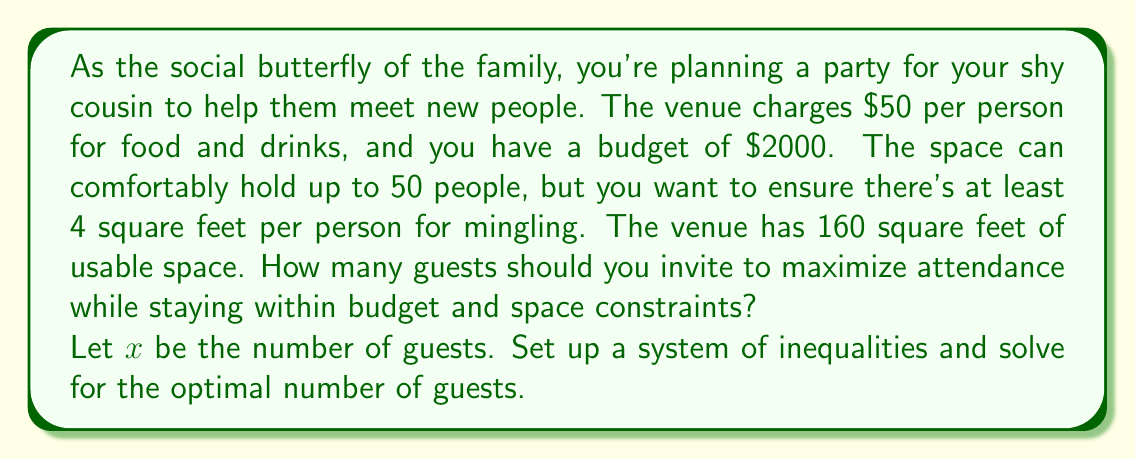Can you answer this question? Let's approach this step-by-step:

1) First, let's set up our inequalities based on the given constraints:

   Budget constraint: $50x \leq 2000$
   Space constraint: $4x \leq 160$
   Maximum capacity: $x \leq 50$

2) Let's solve each inequality:

   From budget: $50x \leq 2000$
                $x \leq 40$

   From space: $4x \leq 160$
               $x \leq 40$

   From capacity: $x \leq 50$

3) The most restrictive constraints are from budget and space, both limiting $x$ to 40.

4) Since we want to maximize attendance, we should choose the largest possible value for $x$ that satisfies all constraints.

5) Therefore, the optimal number of guests is 40.

6) Let's verify:
   - Budget: $50 * 40 = 2000$ (exactly on budget)
   - Space: $4 * 40 = 160$ (using all available space)
   - Capacity: $40 < 50$ (within maximum capacity)

This solution maximizes the number of guests while meeting all constraints.
Answer: The optimal number of guests to invite is 40. 